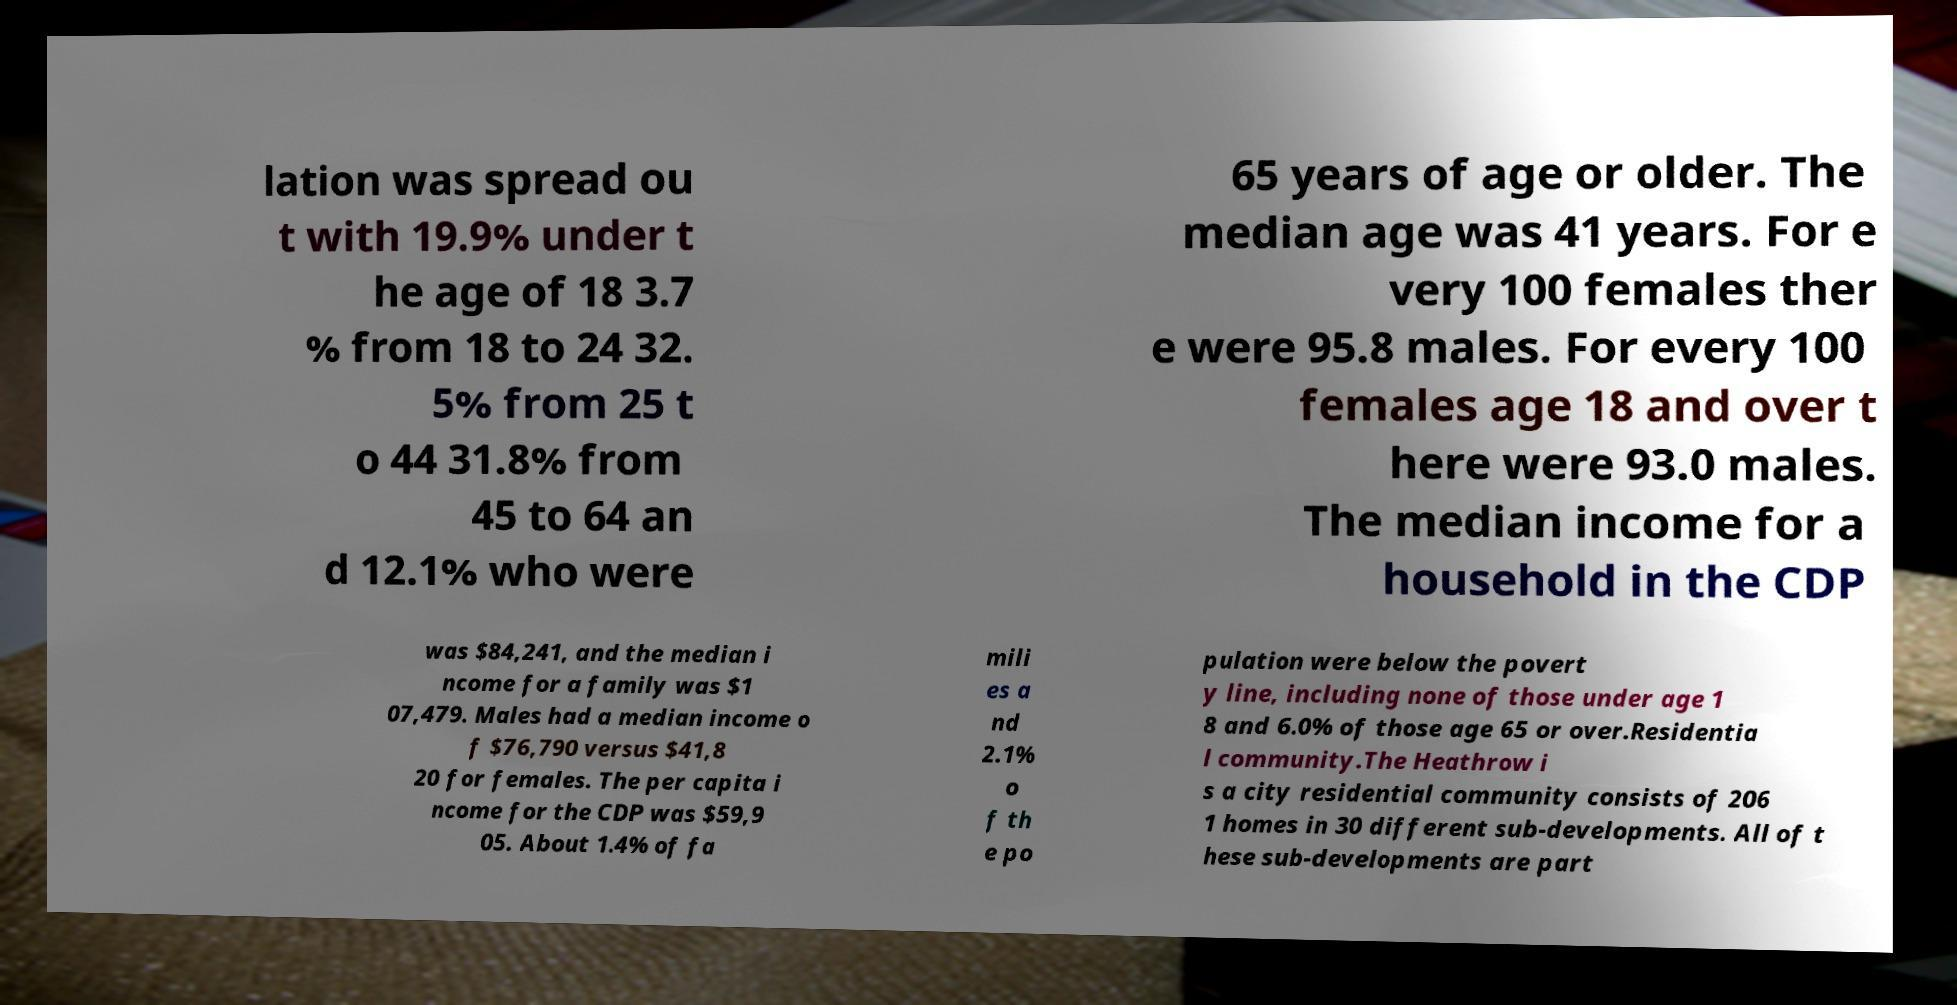Could you assist in decoding the text presented in this image and type it out clearly? lation was spread ou t with 19.9% under t he age of 18 3.7 % from 18 to 24 32. 5% from 25 t o 44 31.8% from 45 to 64 an d 12.1% who were 65 years of age or older. The median age was 41 years. For e very 100 females ther e were 95.8 males. For every 100 females age 18 and over t here were 93.0 males. The median income for a household in the CDP was $84,241, and the median i ncome for a family was $1 07,479. Males had a median income o f $76,790 versus $41,8 20 for females. The per capita i ncome for the CDP was $59,9 05. About 1.4% of fa mili es a nd 2.1% o f th e po pulation were below the povert y line, including none of those under age 1 8 and 6.0% of those age 65 or over.Residentia l community.The Heathrow i s a city residential community consists of 206 1 homes in 30 different sub-developments. All of t hese sub-developments are part 